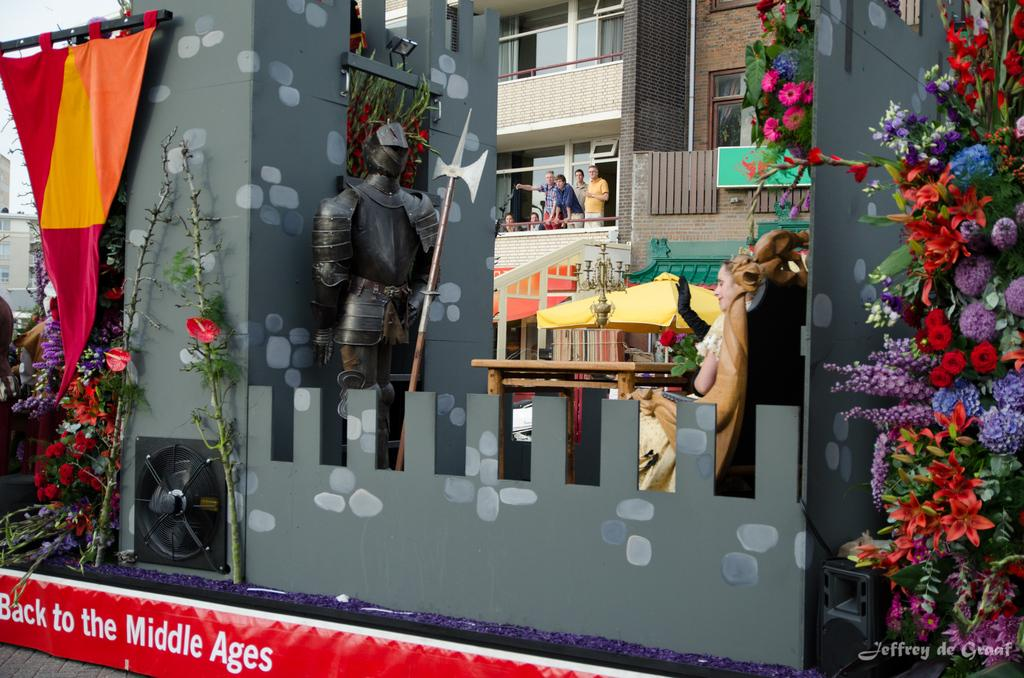<image>
Give a short and clear explanation of the subsequent image. A Back to the Middle Ages parade float with a gray castle and flag. 